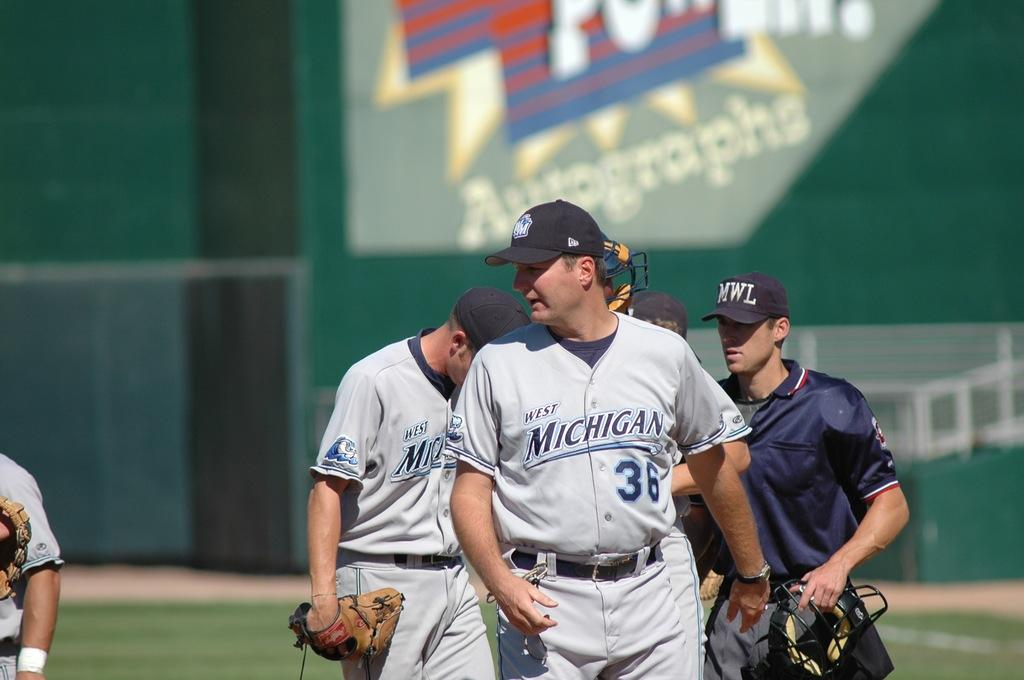<image>
Provide a brief description of the given image. A baseball game with the West Michigan Whitecaps with three players and two umpires on the field. 